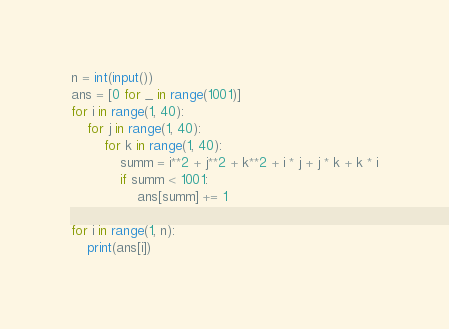<code> <loc_0><loc_0><loc_500><loc_500><_Python_>n = int(input())
ans = [0 for _ in range(1001)]
for i in range(1, 40):
    for j in range(1, 40):
        for k in range(1, 40):
            summ = i**2 + j**2 + k**2 + i * j + j * k + k * i
            if summ < 1001:
                ans[summ] += 1

for i in range(1, n):
    print(ans[i])
</code> 